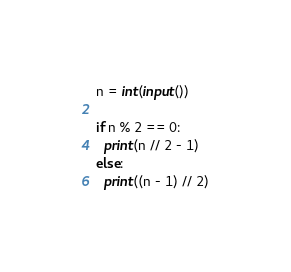Convert code to text. <code><loc_0><loc_0><loc_500><loc_500><_Python_>n = int(input())

if n % 2 == 0:
  print(n // 2 - 1)
else:
  print((n - 1) // 2)</code> 